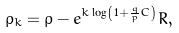Convert formula to latex. <formula><loc_0><loc_0><loc_500><loc_500>\rho _ { k } = \rho - e ^ { k \log \left ( 1 + \frac { q } { p } C \right ) } R ,</formula> 